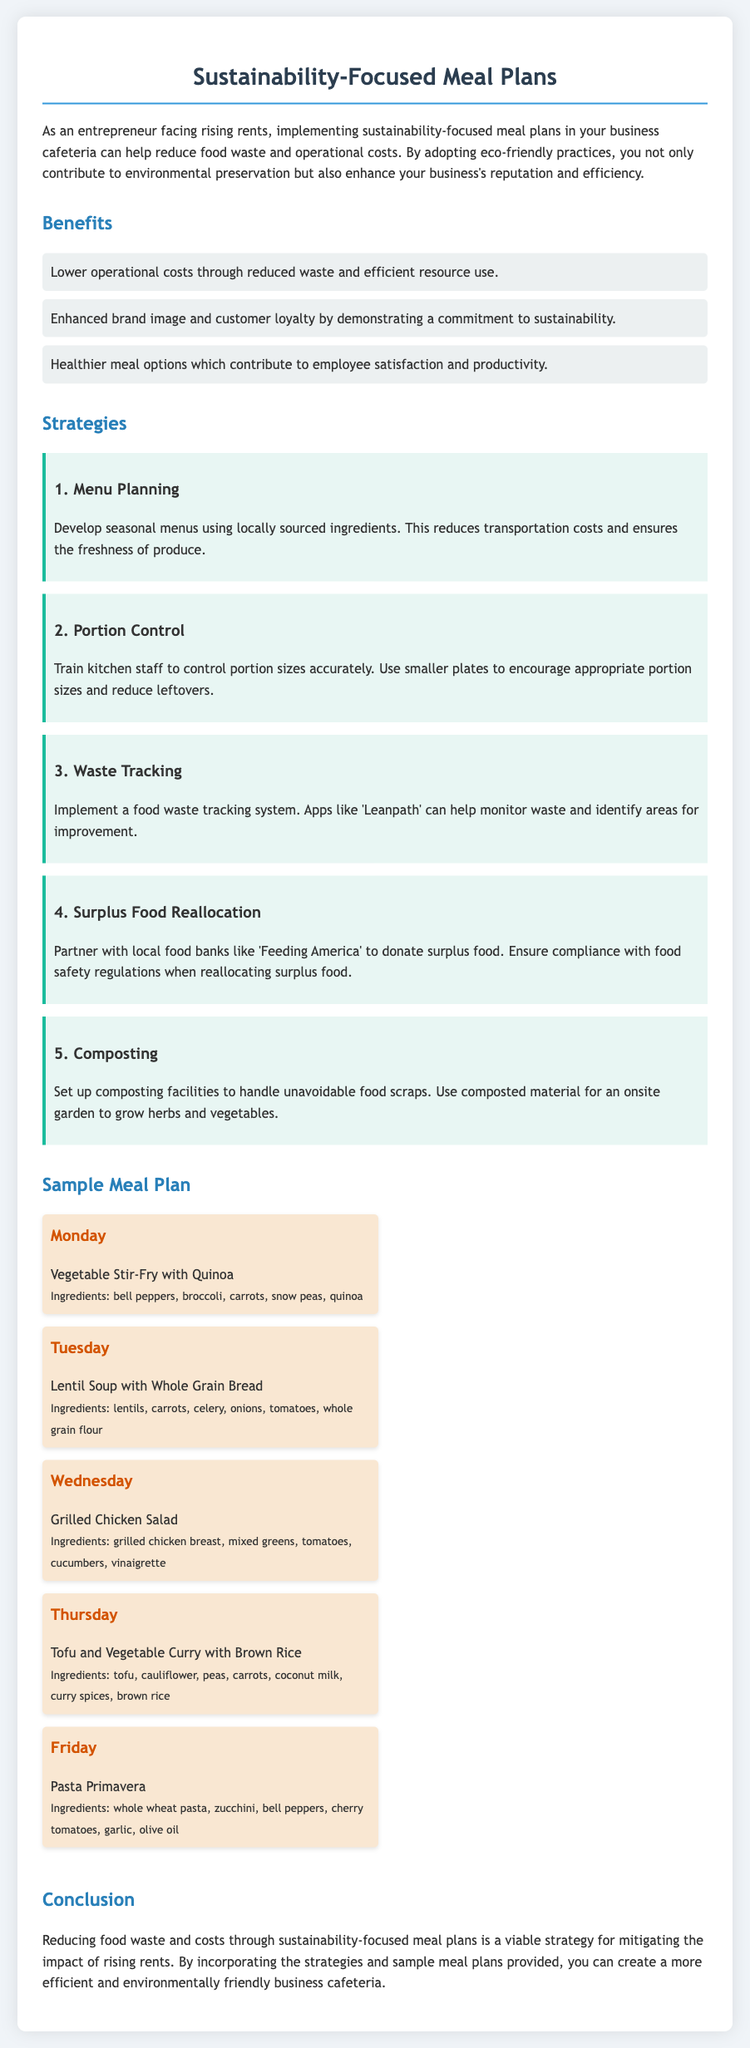What are the benefits of sustainability-focused meal plans? The benefits of sustainability-focused meal plans include lower operational costs through reduced waste, enhanced brand image and customer loyalty, and healthier meal options.
Answer: Lower operational costs, enhanced brand image, healthier meal options What is one strategy suggested for reducing food waste? One of the strategies suggested in the document for reducing food waste is to develop seasonal menus using locally sourced ingredients.
Answer: Menu Planning How many days are included in the sample meal plan? The sample meal plan includes meals from Monday to Friday, which totals five days.
Answer: Five days What dish is served on Wednesday? The meal served on Wednesday is Grilled Chicken Salad.
Answer: Grilled Chicken Salad Which ingredient is used in the Friday meal? The ingredients in the Friday meal, Pasta Primavera, include zucchini, bell peppers, and cherry tomatoes.
Answer: Zucchini What is the purpose of a food waste tracking system? The purpose of a food waste tracking system is to monitor waste and identify areas for improvement.
Answer: Monitor waste How does composting help in sustainability-focused meal plans? Composting helps manage unavoidable food scraps and the composted material can be used for onsite gardening.
Answer: Manage food scraps What is recommended for portion control? Training kitchen staff to control portion sizes accurately and using smaller plates are recommended for portion control.
Answer: Control portion sizes What is the title of the document? The title of the document is "Sustainability-Focused Meal Plans."
Answer: Sustainability-Focused Meal Plans 